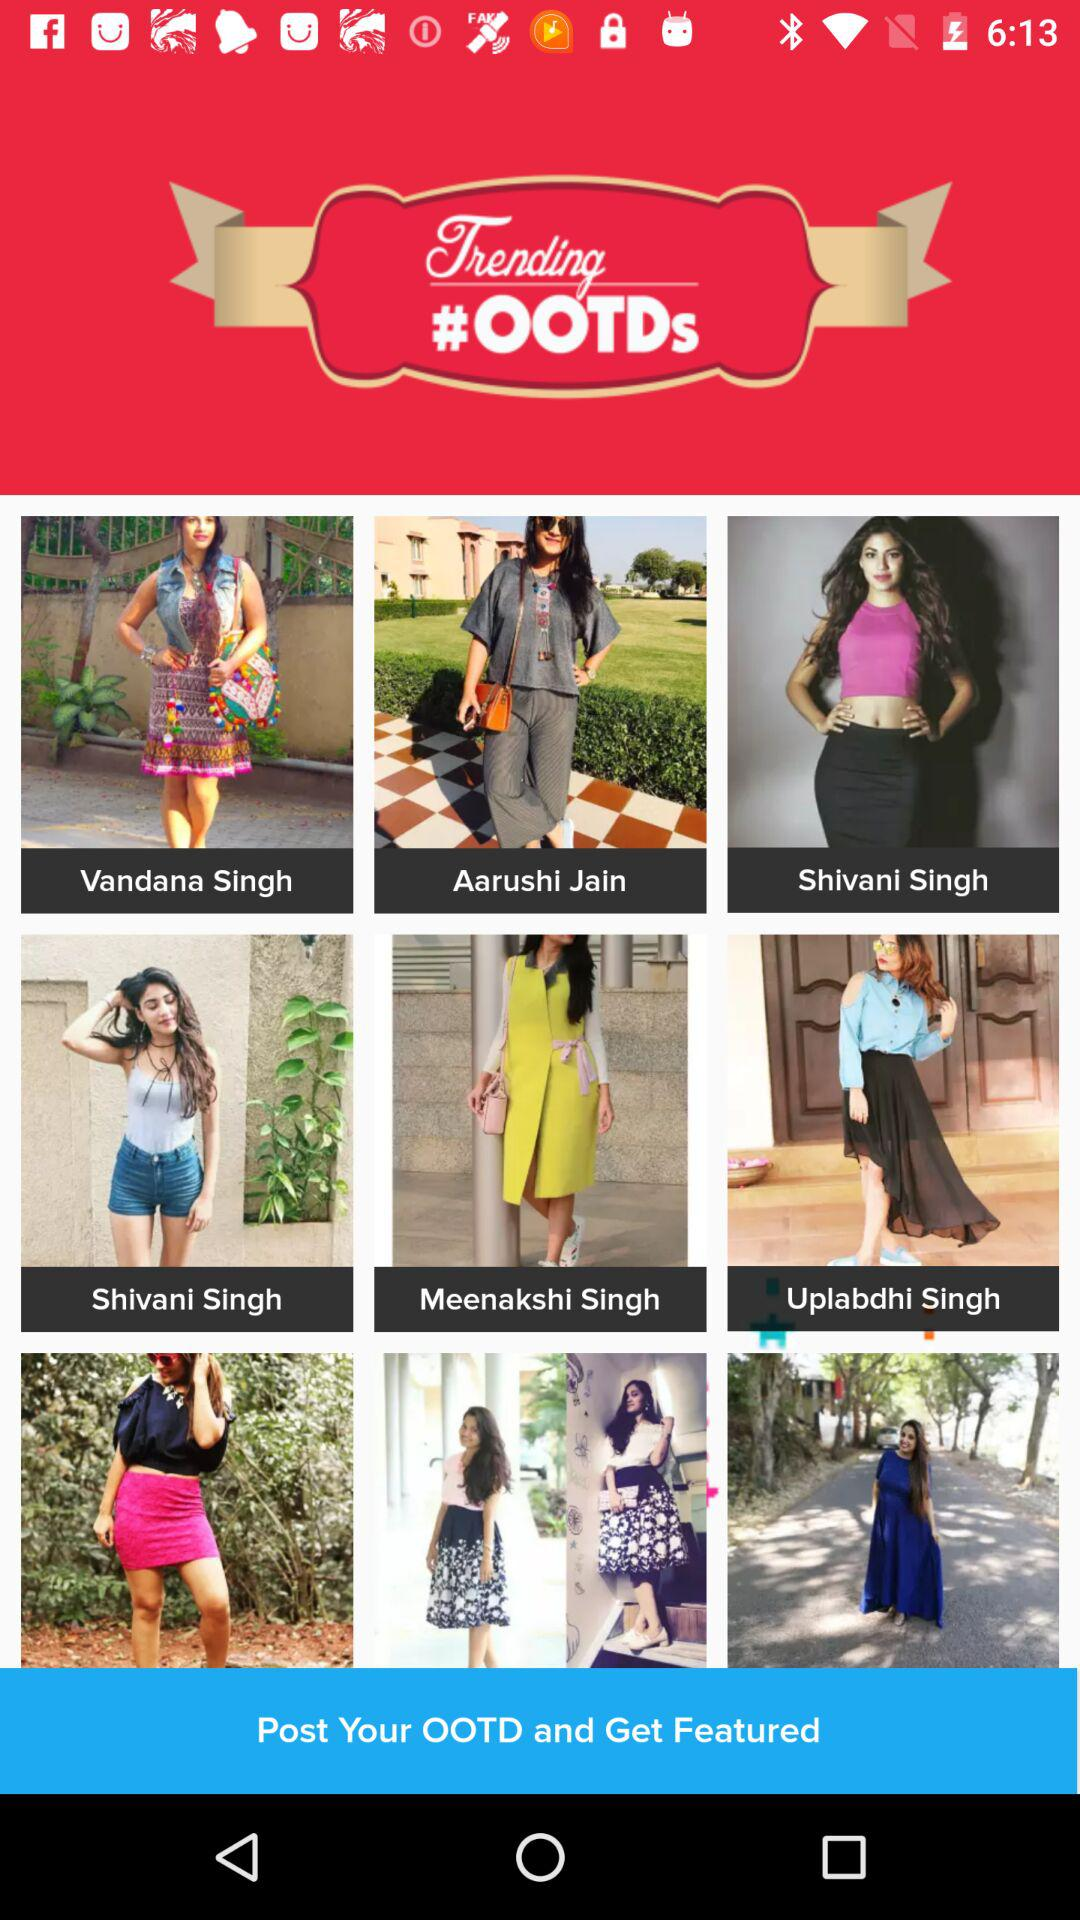What is the name of the application?
When the provided information is insufficient, respond with <no answer>. <no answer> 